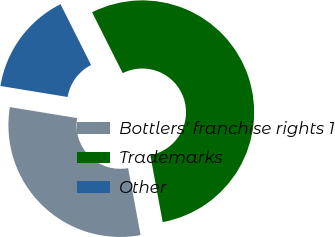Convert chart. <chart><loc_0><loc_0><loc_500><loc_500><pie_chart><fcel>Bottlers' franchise rights 1<fcel>Trademarks<fcel>Other<nl><fcel>30.5%<fcel>54.5%<fcel>15.0%<nl></chart> 